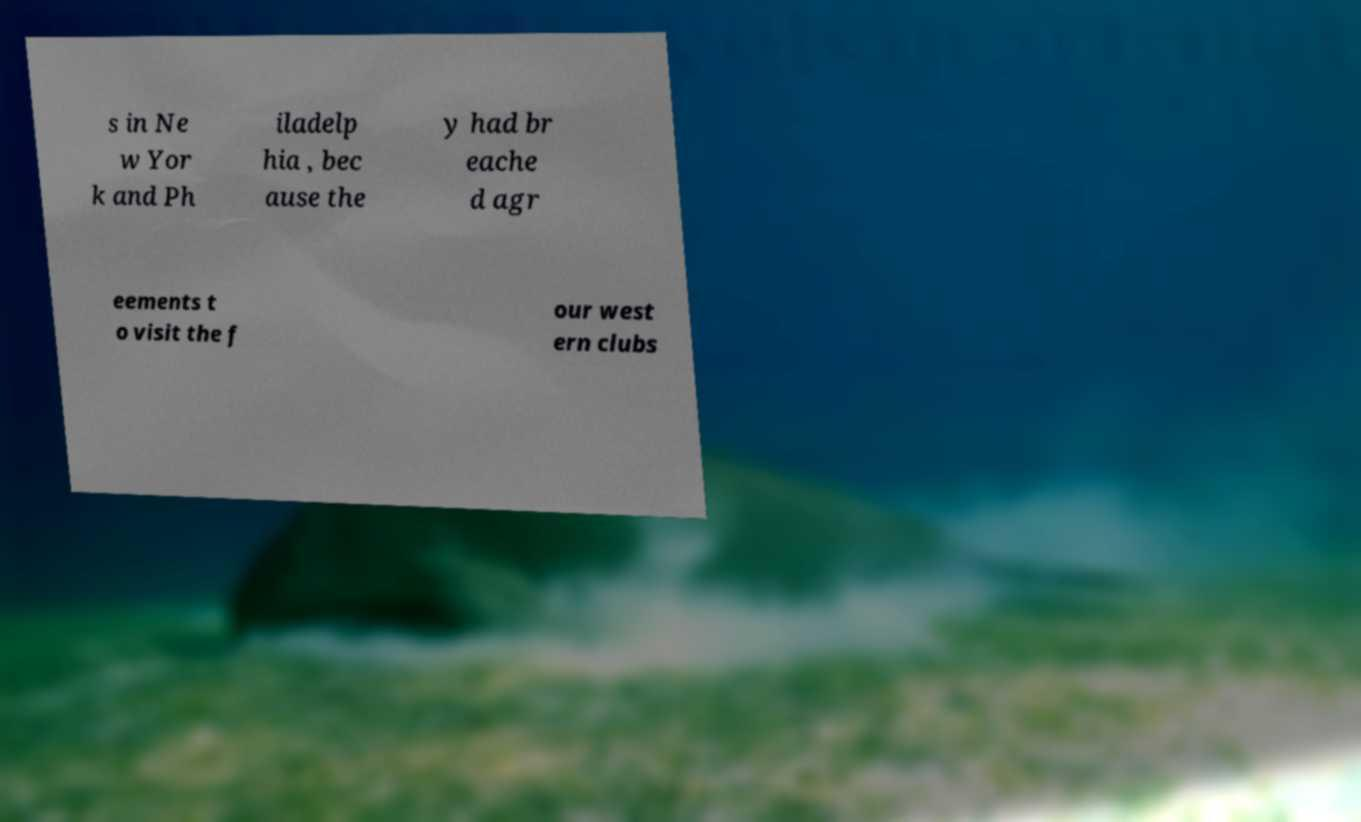Could you assist in decoding the text presented in this image and type it out clearly? s in Ne w Yor k and Ph iladelp hia , bec ause the y had br eache d agr eements t o visit the f our west ern clubs 